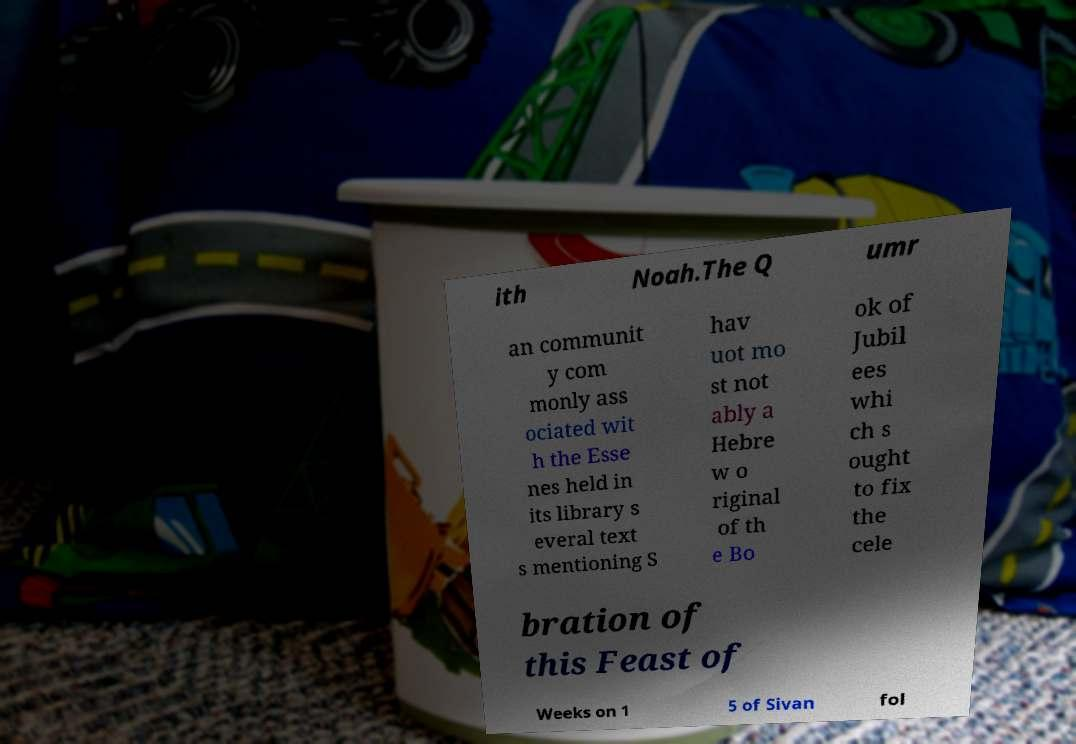Can you accurately transcribe the text from the provided image for me? ith Noah.The Q umr an communit y com monly ass ociated wit h the Esse nes held in its library s everal text s mentioning S hav uot mo st not ably a Hebre w o riginal of th e Bo ok of Jubil ees whi ch s ought to fix the cele bration of this Feast of Weeks on 1 5 of Sivan fol 